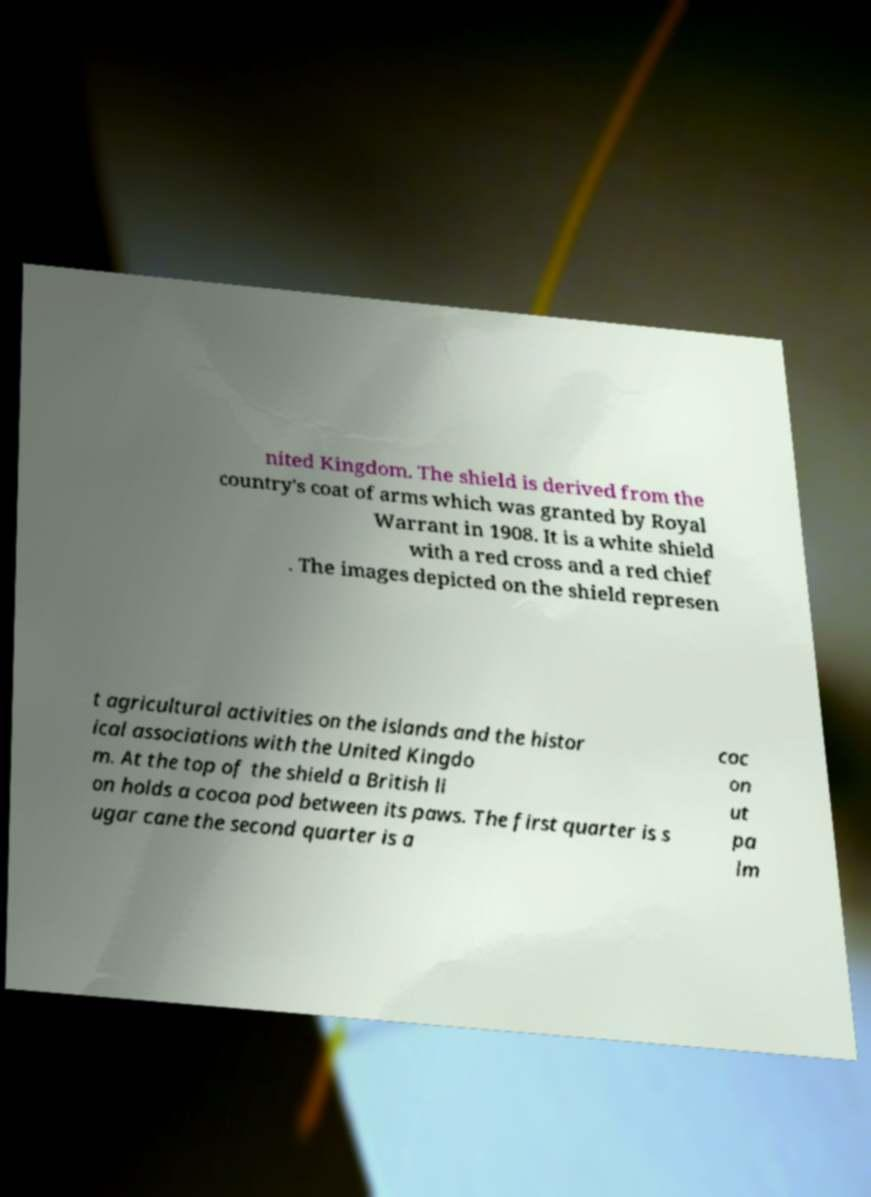There's text embedded in this image that I need extracted. Can you transcribe it verbatim? nited Kingdom. The shield is derived from the country's coat of arms which was granted by Royal Warrant in 1908. It is a white shield with a red cross and a red chief . The images depicted on the shield represen t agricultural activities on the islands and the histor ical associations with the United Kingdo m. At the top of the shield a British li on holds a cocoa pod between its paws. The first quarter is s ugar cane the second quarter is a coc on ut pa lm 